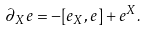<formula> <loc_0><loc_0><loc_500><loc_500>\partial _ { X } e = - [ e _ { X } , e ] + e ^ { X } .</formula> 